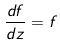<formula> <loc_0><loc_0><loc_500><loc_500>\frac { d f } { d z } = f</formula> 